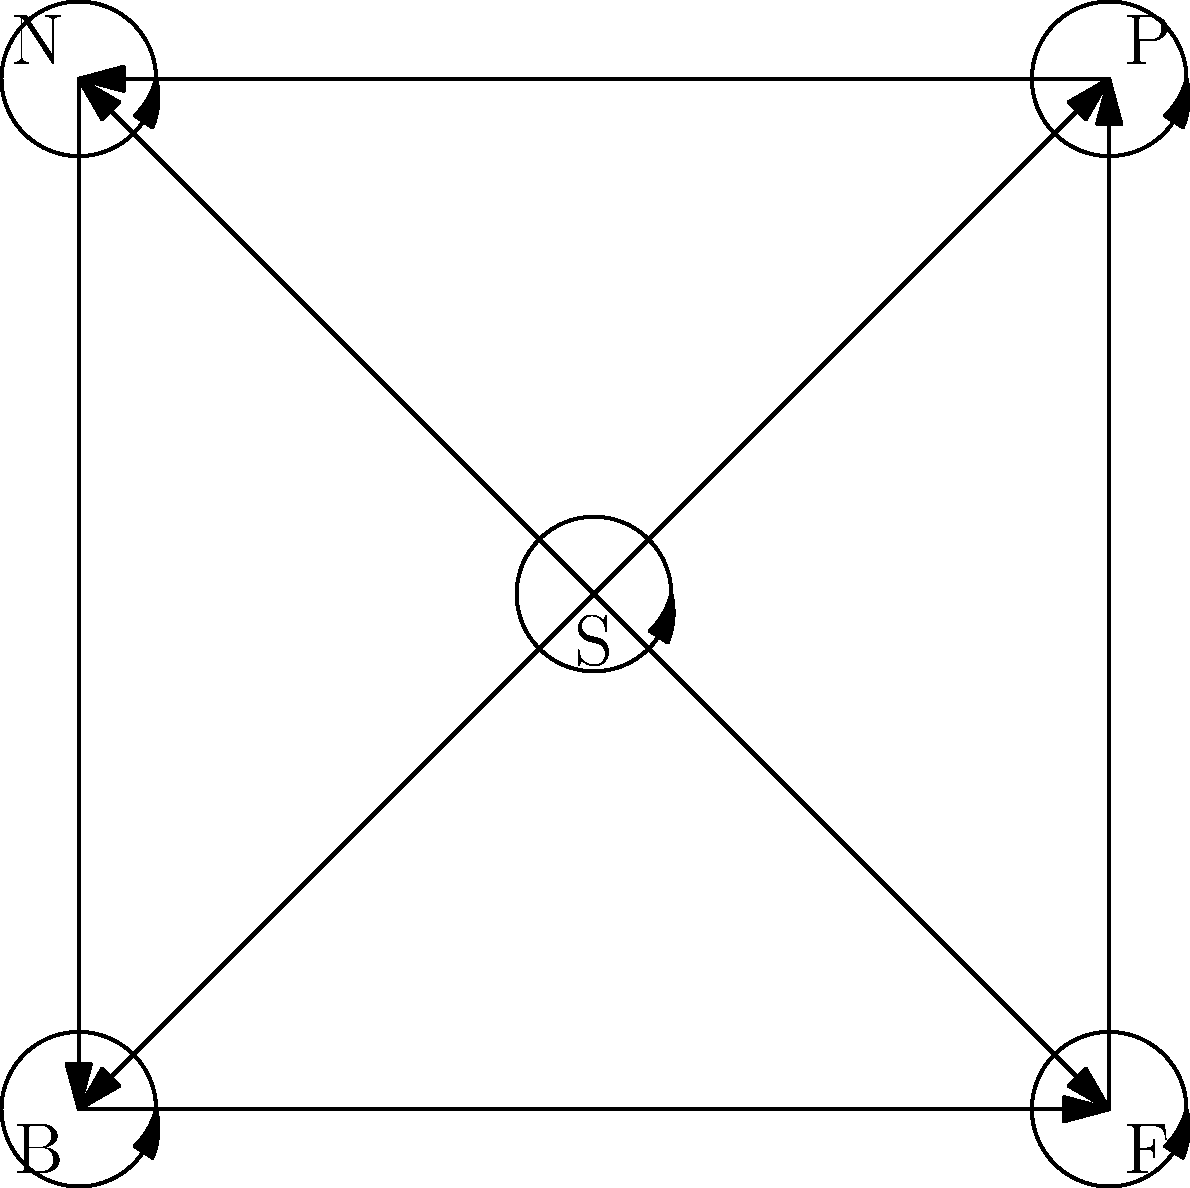As a regular user providing feedback for product improvement, you notice that the company's feedback system can be represented by a Cayley graph. The graph shows different types of feedback: S (Start), P (Positive), N (Negative), B (Bug report), and F (Feature request). If a user submits feedback of each type exactly once in any order, how many unique feedback sequences are possible? To solve this problem, we need to analyze the Cayley graph representation of the feedback system:

1. The graph has 5 vertices representing different types of feedback: S, P, N, B, and F.
2. Each vertex has a self-loop, indicating that multiple feedback of the same type can be submitted consecutively.
3. There are directed edges between all vertices, showing that any type of feedback can be followed by any other type.

To find the number of unique feedback sequences:

1. We need to arrange 5 distinct elements (S, P, N, B, F) in a sequence.
2. This is a permutation problem, as the order matters and each element is used exactly once.
3. The number of permutations of n distinct elements is given by the factorial of n: n!

In this case:
$$n = 5$$
Number of unique sequences = $$5! = 5 \times 4 \times 3 \times 2 \times 1 = 120$$

Therefore, there are 120 unique feedback sequences possible when a user submits each type of feedback exactly once in any order.
Answer: 120 